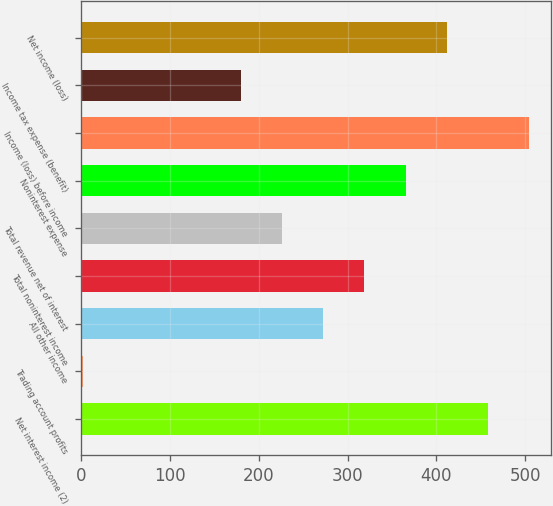Convert chart. <chart><loc_0><loc_0><loc_500><loc_500><bar_chart><fcel>Net interest income (2)<fcel>Trading account profits<fcel>All other income<fcel>Total noninterest income<fcel>Total revenue net of interest<fcel>Noninterest expense<fcel>Income (loss) before income<fcel>Income tax expense (benefit)<fcel>Net income (loss)<nl><fcel>457.8<fcel>3<fcel>272.6<fcel>318.9<fcel>226.3<fcel>365.2<fcel>504.1<fcel>180<fcel>411.5<nl></chart> 